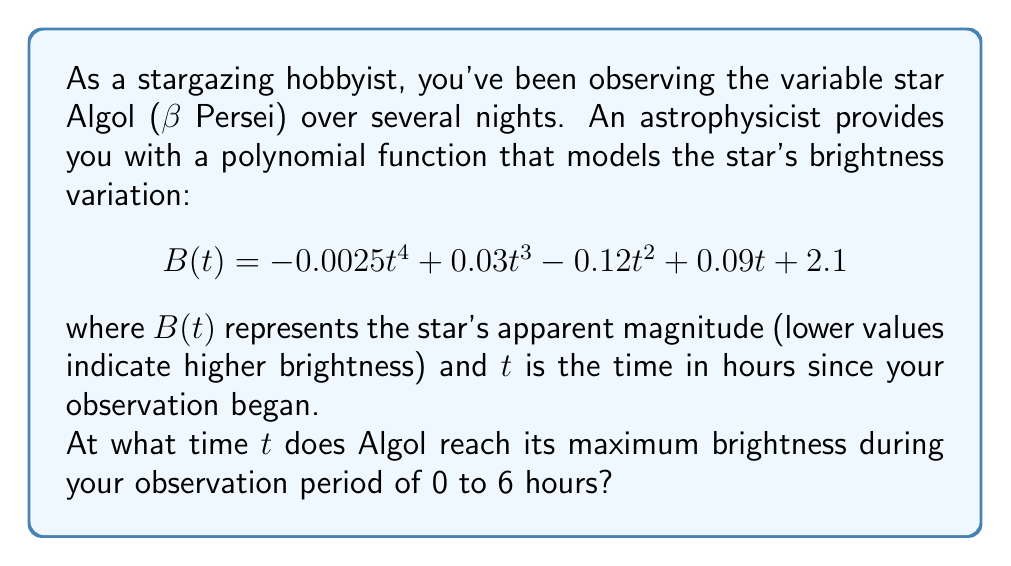Help me with this question. To find the time when Algol reaches its maximum brightness, we need to follow these steps:

1) Recall that for apparent magnitude, lower values indicate higher brightness. So, we're looking for the minimum value of $B(t)$.

2) To find the minimum of a polynomial function, we need to find where its derivative equals zero and confirm it's a minimum point.

3) Let's calculate the derivative of $B(t)$:

   $$ B'(t) = -0.01t^3 + 0.09t^2 - 0.24t + 0.09 $$

4) Set $B'(t) = 0$ and solve:

   $$ -0.01t^3 + 0.09t^2 - 0.24t + 0.09 = 0 $$

5) This cubic equation is difficult to solve by hand. Using a graphing calculator or computer algebra system, we find the roots are approximately:

   $t ≈ -2.37, 1.5, 3.87$

6) Since our observation period is from 0 to 6 hours, we're only interested in the roots 1.5 and 3.87.

7) To determine which of these is a minimum, we can check the second derivative:

   $$ B''(t) = -0.03t^2 + 0.18t - 0.24 $$

8) Evaluating $B''(1.5)$ and $B''(3.87)$:

   $B''(1.5) ≈ -0.0675$ (negative, so local minimum)
   $B''(3.87) ≈ 0.1617$ (positive, so local maximum)

9) Therefore, the brightness reaches its maximum (B(t) reaches its minimum) at $t ≈ 1.5$ hours.
Answer: Algol reaches its maximum brightness approximately 1.5 hours after the start of the observation period. 